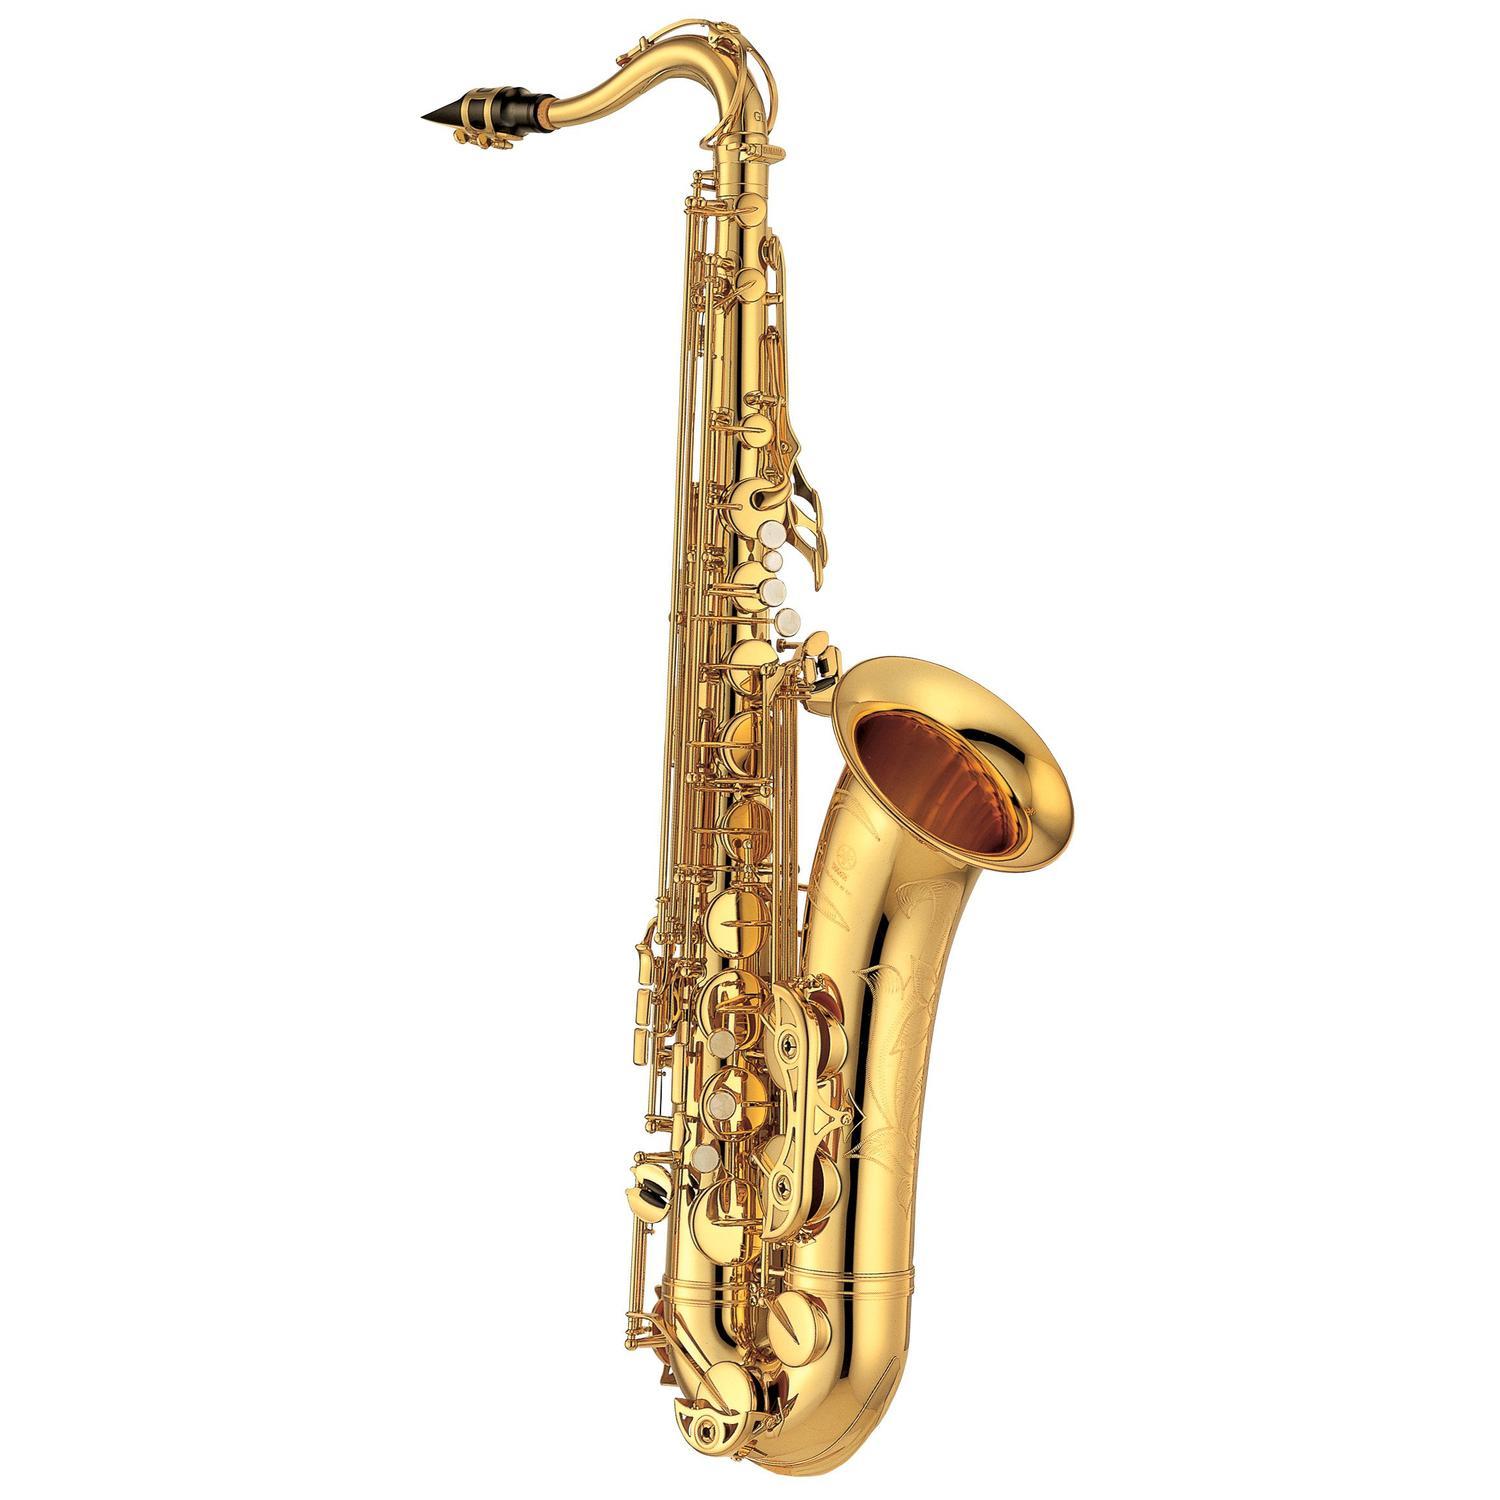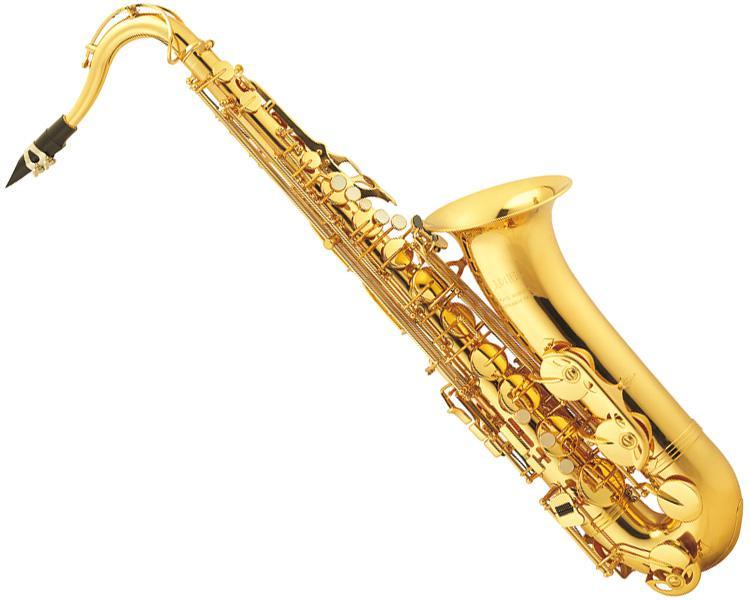The first image is the image on the left, the second image is the image on the right. For the images shown, is this caption "The saxophone on the left is standing straight up and down." true? Answer yes or no. Yes. The first image is the image on the left, the second image is the image on the right. Analyze the images presented: Is the assertion "One saxophone is displayed vertically, and the other is displayed at an angle with the bell-side upturned and the mouthpiece at the upper left." valid? Answer yes or no. Yes. 